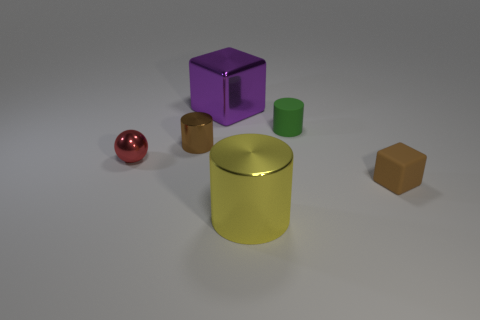Subtract all metallic cylinders. How many cylinders are left? 1 Subtract all brown blocks. How many blocks are left? 1 Add 1 big cyan cubes. How many objects exist? 7 Subtract all blocks. How many objects are left? 4 Add 5 metallic spheres. How many metallic spheres exist? 6 Subtract 0 blue blocks. How many objects are left? 6 Subtract all blue cubes. Subtract all purple cylinders. How many cubes are left? 2 Subtract all gray blocks. How many green cylinders are left? 1 Subtract all tiny green cylinders. Subtract all tiny gray matte cylinders. How many objects are left? 5 Add 3 cubes. How many cubes are left? 5 